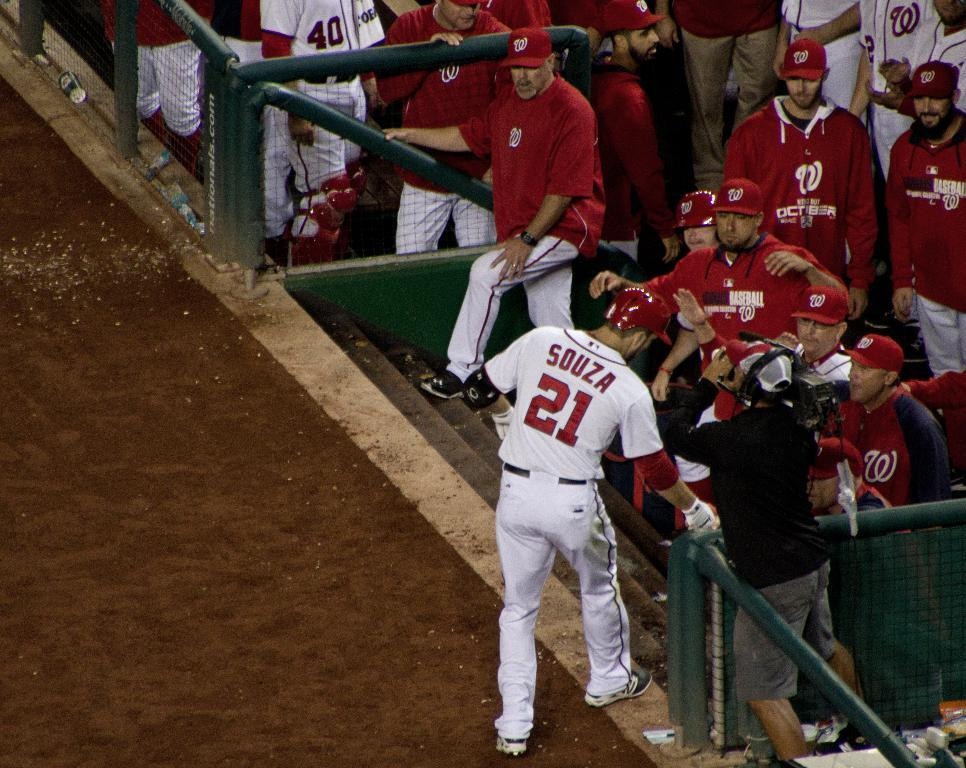<image>
Describe the image concisely. A player wearing a white shirt with the name Souza and the number 21. 